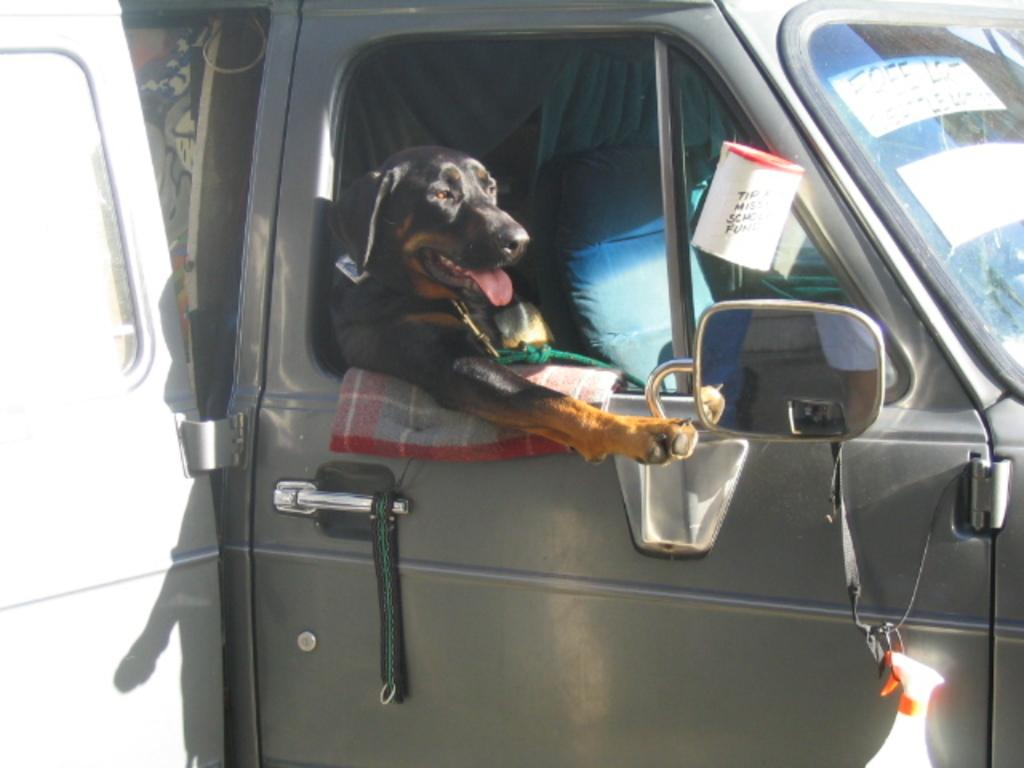What type of animal is in the image? There is a black dog in the image. Where is the dog located? The dog is sitting in a car. What is the dog doing in the car? The dog is keeping her head outside the car window. What type of rhythm is the crow tapping on the car window in the image? There is no crow present in the image, and therefore no rhythm can be observed. 